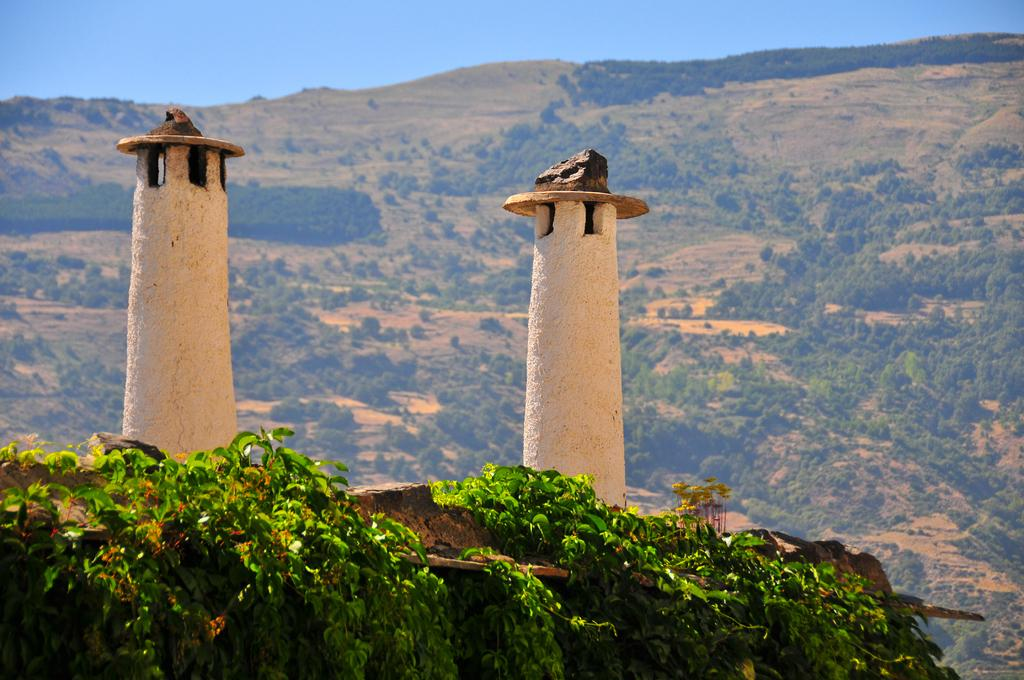How many lighthouses can be seen in the image? There are two lighthouses in the image. What type of vegetation is present in the image? There are green leaves in the image. What can be seen in the background of the image? Trees and mountains are visible in the background. What is the color of the sky in the image? The sky is blue in color. What type of party is happening near the lighthouses in the image? There is no party visible in the image; it only features two lighthouses, green leaves, trees and mountains in the background, and a blue sky. 